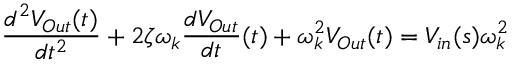Convert formula to latex. <formula><loc_0><loc_0><loc_500><loc_500>\frac { d ^ { 2 } V _ { O u t } ( t ) } { d t ^ { 2 } } + 2 \zeta \omega _ { k } \frac { d V _ { O u t } } { d t } ( t ) + \omega _ { k } ^ { 2 } V _ { O u t } ( t ) = V _ { i n } ( s ) \omega _ { k } ^ { 2 }</formula> 